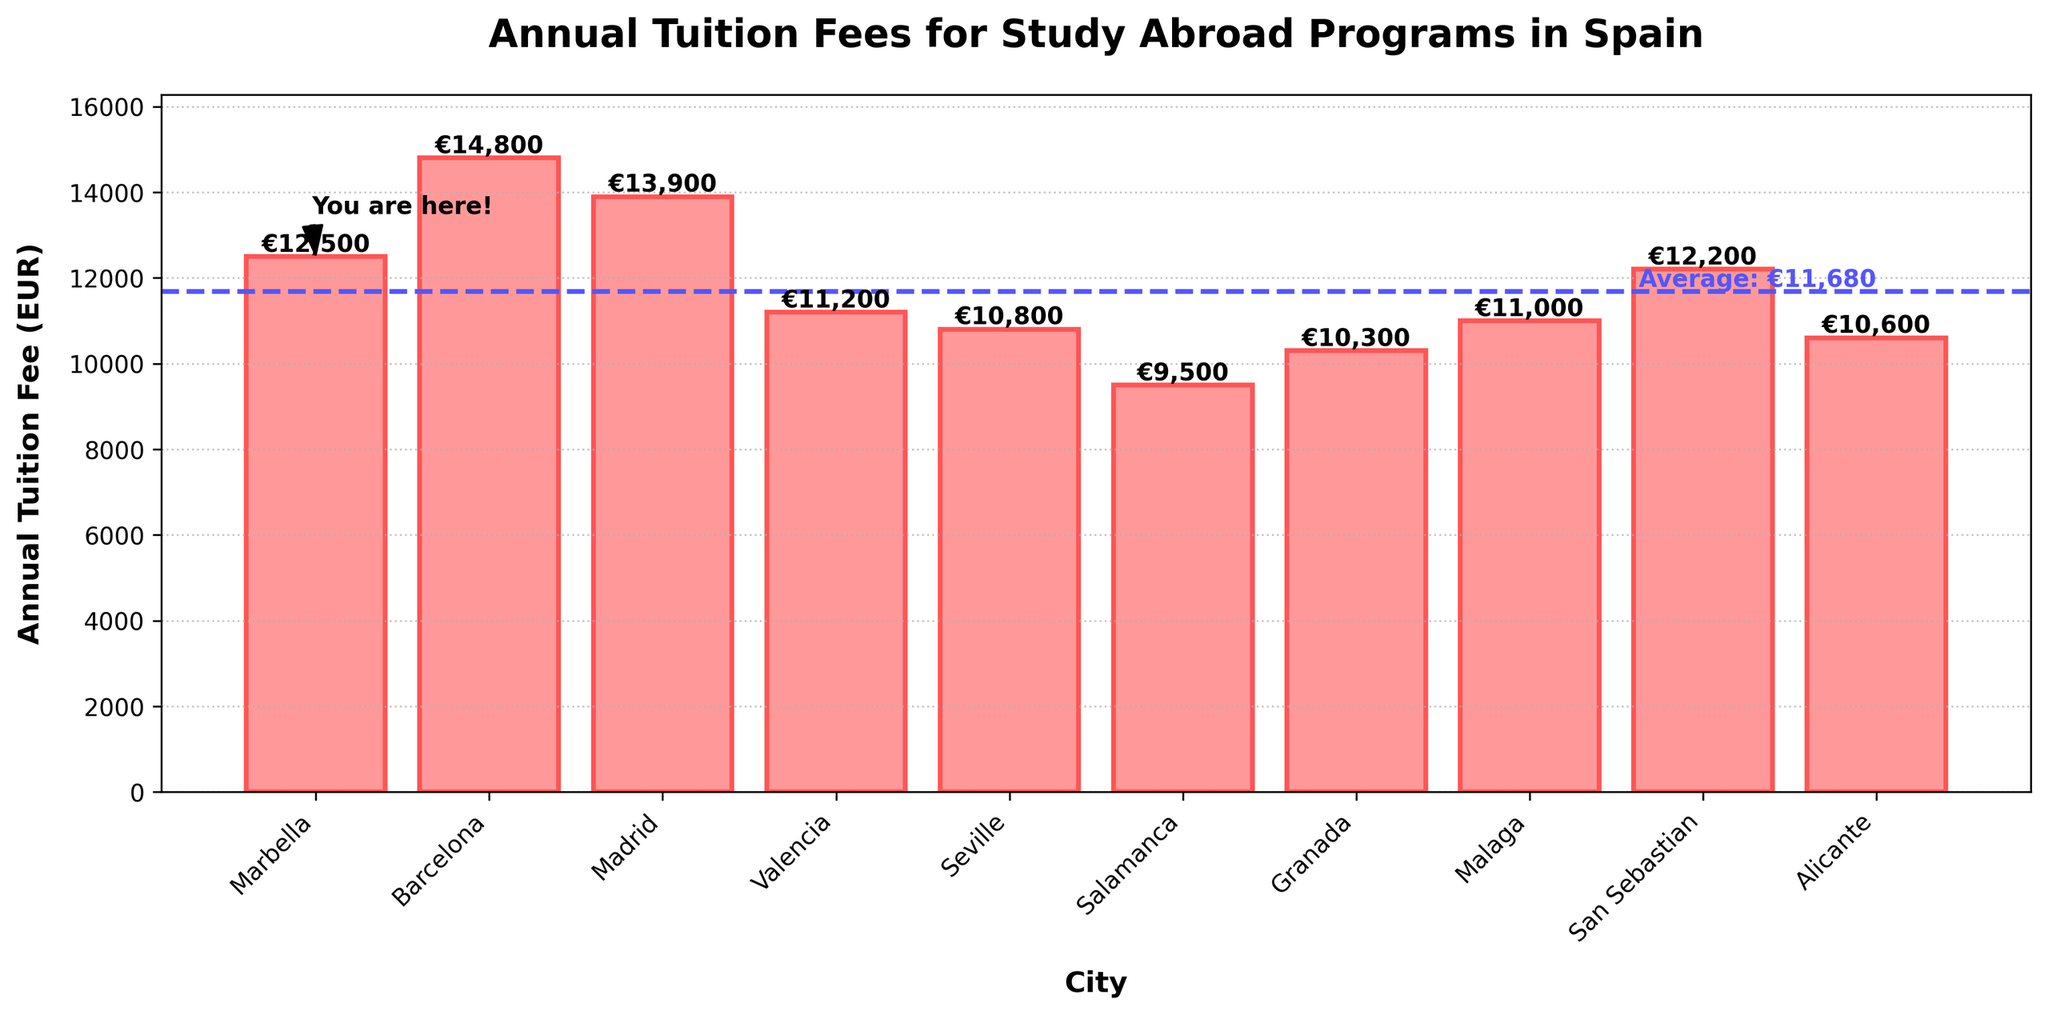what is the average annual tuition fee across all cities? First, sum up the tuition fees for all cities: 12,500+14,800+13,900+11,200+10,800+9,500+10,300+11,000+12,200+10,600=117,800. Then, divide this sum by the number of cities (10). 117,800 / 10 = 11,780
Answer: 11,780 Which city has the highest annual tuition fee, and how much is it? Look at the bar chart and find the tallest bar, which corresponds to Barcelona with a fee of 14,800 EUR.
Answer: Barcelona, 14,800 EUR Which cities have annual tuition fees lower than 11,000 EUR? Check the height of each bar compared to the 11,000 EUR mark. Salamanca, Seville, Granada, and Alicante have fees lower than 11,000 EUR.
Answer: Salamanca, Seville, Granada, and Alicante How much higher is the annual tuition fee in Barcelona compared to Seville? Subtract Seville's fee from Barcelona's fee: 14,800 - 10,800 = 4,000 EUR.
Answer: 4,000 EUR What is the range of annual tuition fees across the cities? Find the difference between the highest fee (Barcelona) and the lowest fee (Salamanca): 14,800 - 9,500 = 5,300 EUR.
Answer: 5,300 EUR Which city is closest to the average annual tuition fee, and what is its fee? First, calculate the average fee, which is 11,780 EUR. Then, compare the fees to see which is closest: Granada at 10,300 EUR is 1,480 EUR below the average, and San Sebastian at 12,200 EUR is 420 EUR above the average. Thus, San Sebastian is closest.
Answer: San Sebastian, 12,200 EUR What is the difference in annual tuition fee between Madrid and Marbella? Subtract Marbella's fee from Madrid's fee: 13,900 - 12,500 = 1,400 EUR.
Answer: 1,400 EUR Which city has the lowest annual tuition fee, and how much is it? Look at the bar chart and find the shortest bar, which corresponds to Salamanca with a fee of 9,500 EUR.
Answer: Salamanca, 9,500 EUR How many cities have an annual tuition fee above the average? Calculate the average fee, which is 11,780 EUR, and then count the bars with fees above this value: Marbella, Barcelona, Madrid, San Sebastian. Four cities fit this criterion.
Answer: Four cities By how much does the annual tuition fee in San Sebastian exceed that of Granada? Subtract Granada's fee from San Sebastian's fee: 12,200 - 10,300 = 1,900 EUR.
Answer: 1,900 EUR 